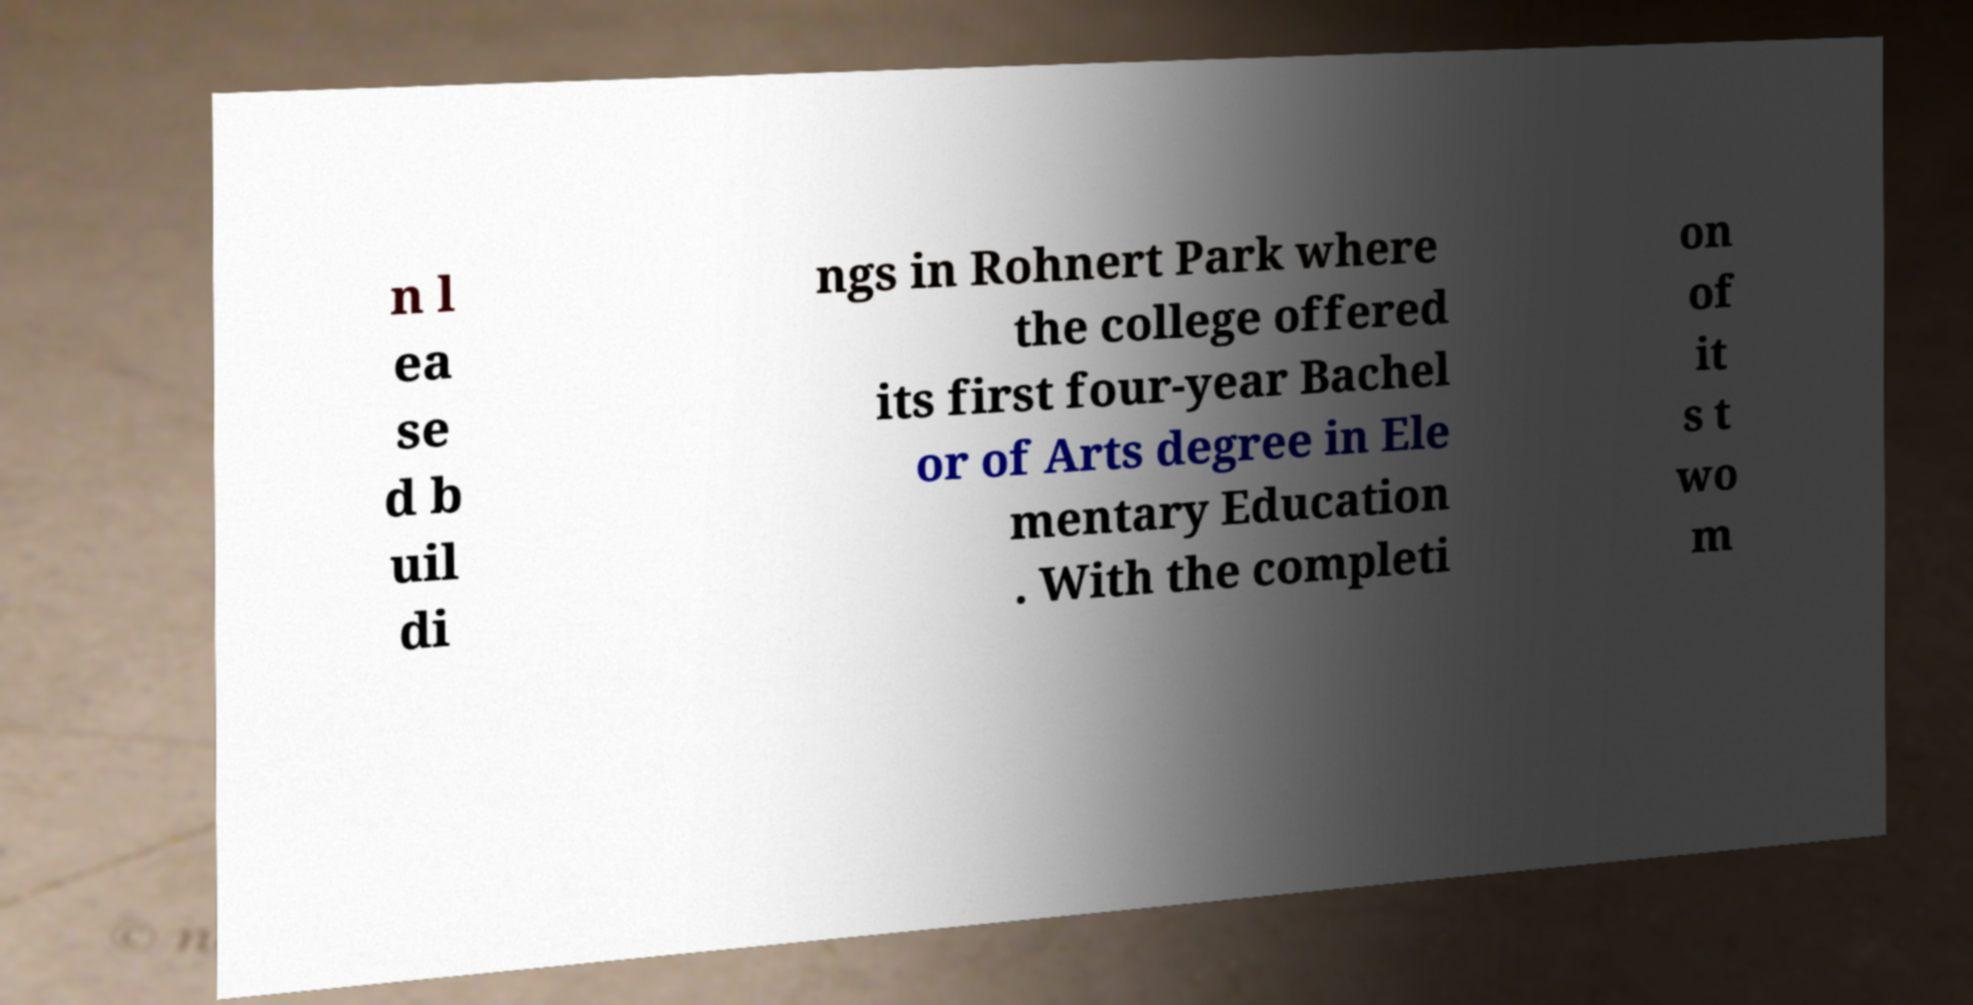Please read and relay the text visible in this image. What does it say? n l ea se d b uil di ngs in Rohnert Park where the college offered its first four-year Bachel or of Arts degree in Ele mentary Education . With the completi on of it s t wo m 